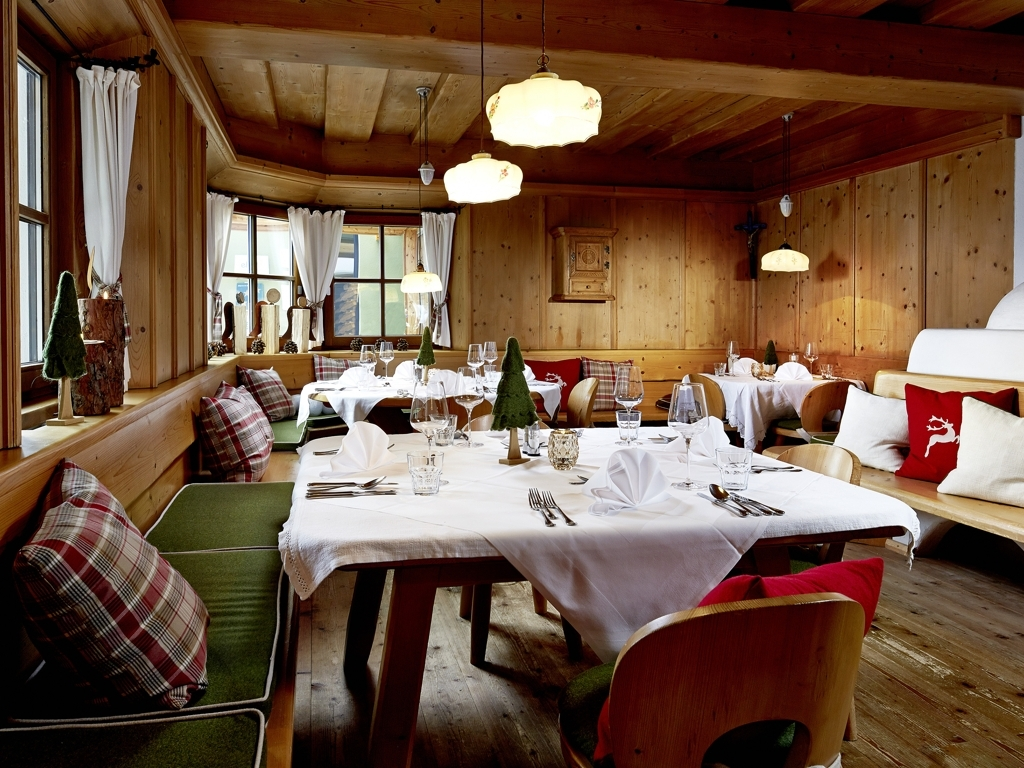What style or theme does the interior design of this place suggest? The interior design suggests a rustic alpine or chalet theme, heavily featuring natural wood finishes, which evoke a traditional mountain retreat. The decor includes plaid fabrics and accents of colors that are evocative of an earthy palette. Cushions with deer motifs add to the alpine charm. Overall, the setting appears designed to create a cozy and intimate atmosphere that is both welcoming and reflective of a natural setting, likely found in a location surrounded by nature. 